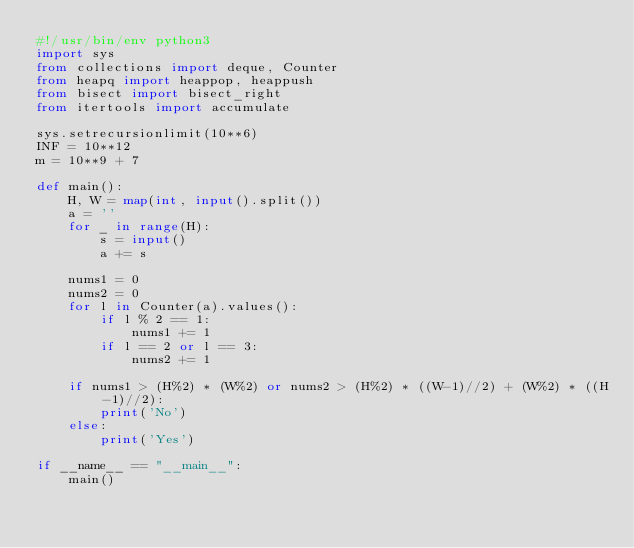Convert code to text. <code><loc_0><loc_0><loc_500><loc_500><_Python_>#!/usr/bin/env python3
import sys
from collections import deque, Counter
from heapq import heappop, heappush
from bisect import bisect_right
from itertools import accumulate

sys.setrecursionlimit(10**6)
INF = 10**12
m = 10**9 + 7

def main():
    H, W = map(int, input().split())
    a = ''
    for _ in range(H):
        s = input()
        a += s
    
    nums1 = 0
    nums2 = 0
    for l in Counter(a).values():
        if l % 2 == 1:
            nums1 += 1
        if l == 2 or l == 3:
            nums2 += 1

    if nums1 > (H%2) * (W%2) or nums2 > (H%2) * ((W-1)//2) + (W%2) * ((H-1)//2):
        print('No')
    else:
        print('Yes')

if __name__ == "__main__":
    main()
</code> 